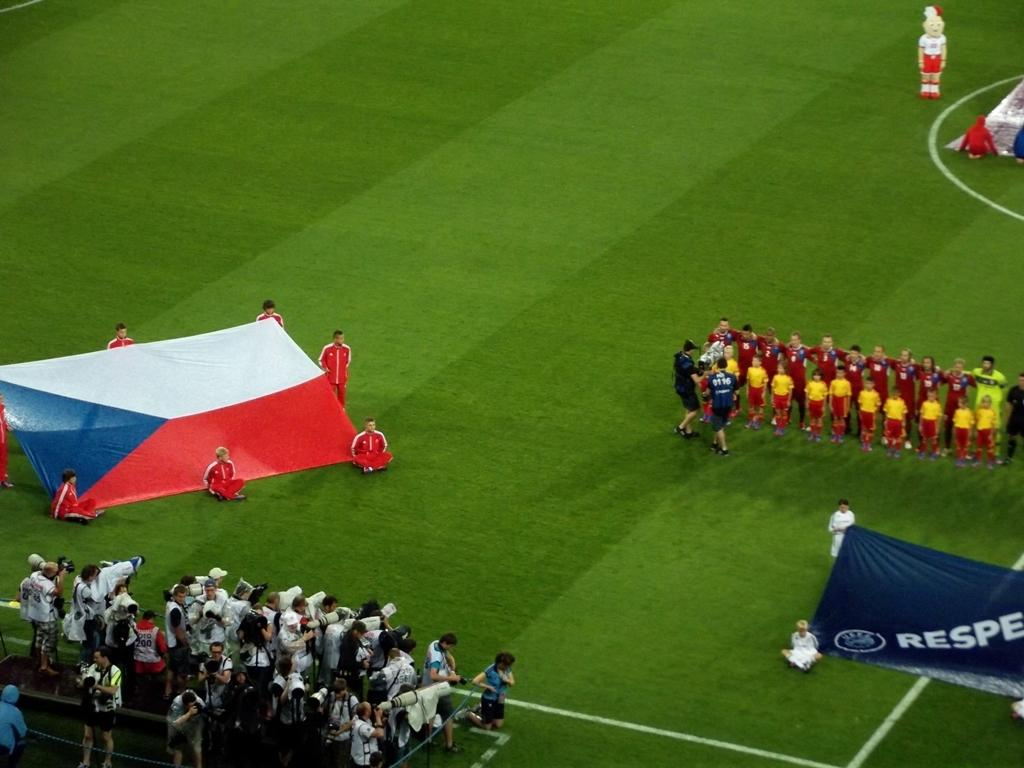What are the people in the image doing? Some people are standing, some are sitting, and some are holding flags in the image. Can you describe the crowd in the image? There is a crowd at the bottom of the image. What is the location of the clown in the image? The clown is on the left side of the image. What type of voice can be heard coming from the clown in the image? There is no indication of sound or voice in the image, so it cannot be determined from the image. 